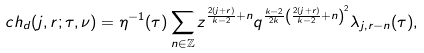<formula> <loc_0><loc_0><loc_500><loc_500>c h _ { d } ( j , r ; \tau , \nu ) = \eta ^ { - 1 } ( \tau ) \sum _ { n \in \mathbb { Z } } z ^ { \frac { 2 ( j + r ) } { k - 2 } + n } q ^ { \frac { k - 2 } { 2 k } \left ( \frac { 2 ( j + r ) } { k - 2 } + n \right ) ^ { 2 } } \lambda _ { j , r - n } ( \tau ) ,</formula> 